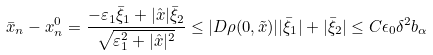Convert formula to latex. <formula><loc_0><loc_0><loc_500><loc_500>\bar { x } _ { n } - x _ { n } ^ { 0 } = \frac { - \varepsilon _ { 1 } \bar { \xi } _ { 1 } + | \hat { x } | \bar { \xi } _ { 2 } } { \sqrt { \varepsilon _ { 1 } ^ { 2 } + | \hat { x } | ^ { 2 } } } \leq | D \rho ( 0 , \tilde { x } ) | | \bar { \xi } _ { 1 } | + | \bar { \xi } _ { 2 } | \leq C \epsilon _ { 0 } \delta ^ { 2 } b _ { \alpha }</formula> 